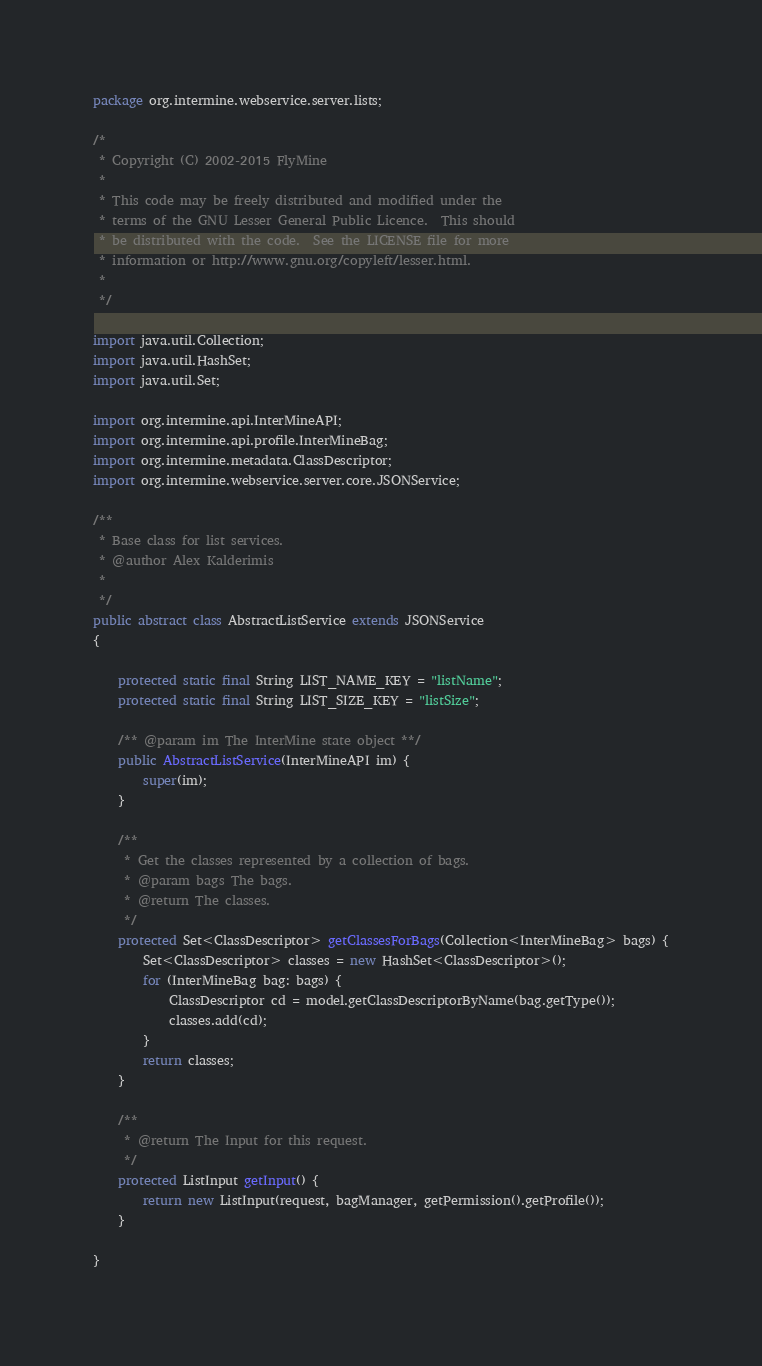Convert code to text. <code><loc_0><loc_0><loc_500><loc_500><_Java_>package org.intermine.webservice.server.lists;

/*
 * Copyright (C) 2002-2015 FlyMine
 *
 * This code may be freely distributed and modified under the
 * terms of the GNU Lesser General Public Licence.  This should
 * be distributed with the code.  See the LICENSE file for more
 * information or http://www.gnu.org/copyleft/lesser.html.
 *
 */

import java.util.Collection;
import java.util.HashSet;
import java.util.Set;

import org.intermine.api.InterMineAPI;
import org.intermine.api.profile.InterMineBag;
import org.intermine.metadata.ClassDescriptor;
import org.intermine.webservice.server.core.JSONService;

/**
 * Base class for list services.
 * @author Alex Kalderimis
 *
 */
public abstract class AbstractListService extends JSONService
{

    protected static final String LIST_NAME_KEY = "listName";
    protected static final String LIST_SIZE_KEY = "listSize";

    /** @param im The InterMine state object **/
    public AbstractListService(InterMineAPI im) {
        super(im);
    }

    /**
     * Get the classes represented by a collection of bags.
     * @param bags The bags.
     * @return The classes.
     */
    protected Set<ClassDescriptor> getClassesForBags(Collection<InterMineBag> bags) {
        Set<ClassDescriptor> classes = new HashSet<ClassDescriptor>();
        for (InterMineBag bag: bags) {
            ClassDescriptor cd = model.getClassDescriptorByName(bag.getType());
            classes.add(cd);
        }
        return classes;
    }

    /**
     * @return The Input for this request.
     */
    protected ListInput getInput() {
        return new ListInput(request, bagManager, getPermission().getProfile());
    }

}
</code> 